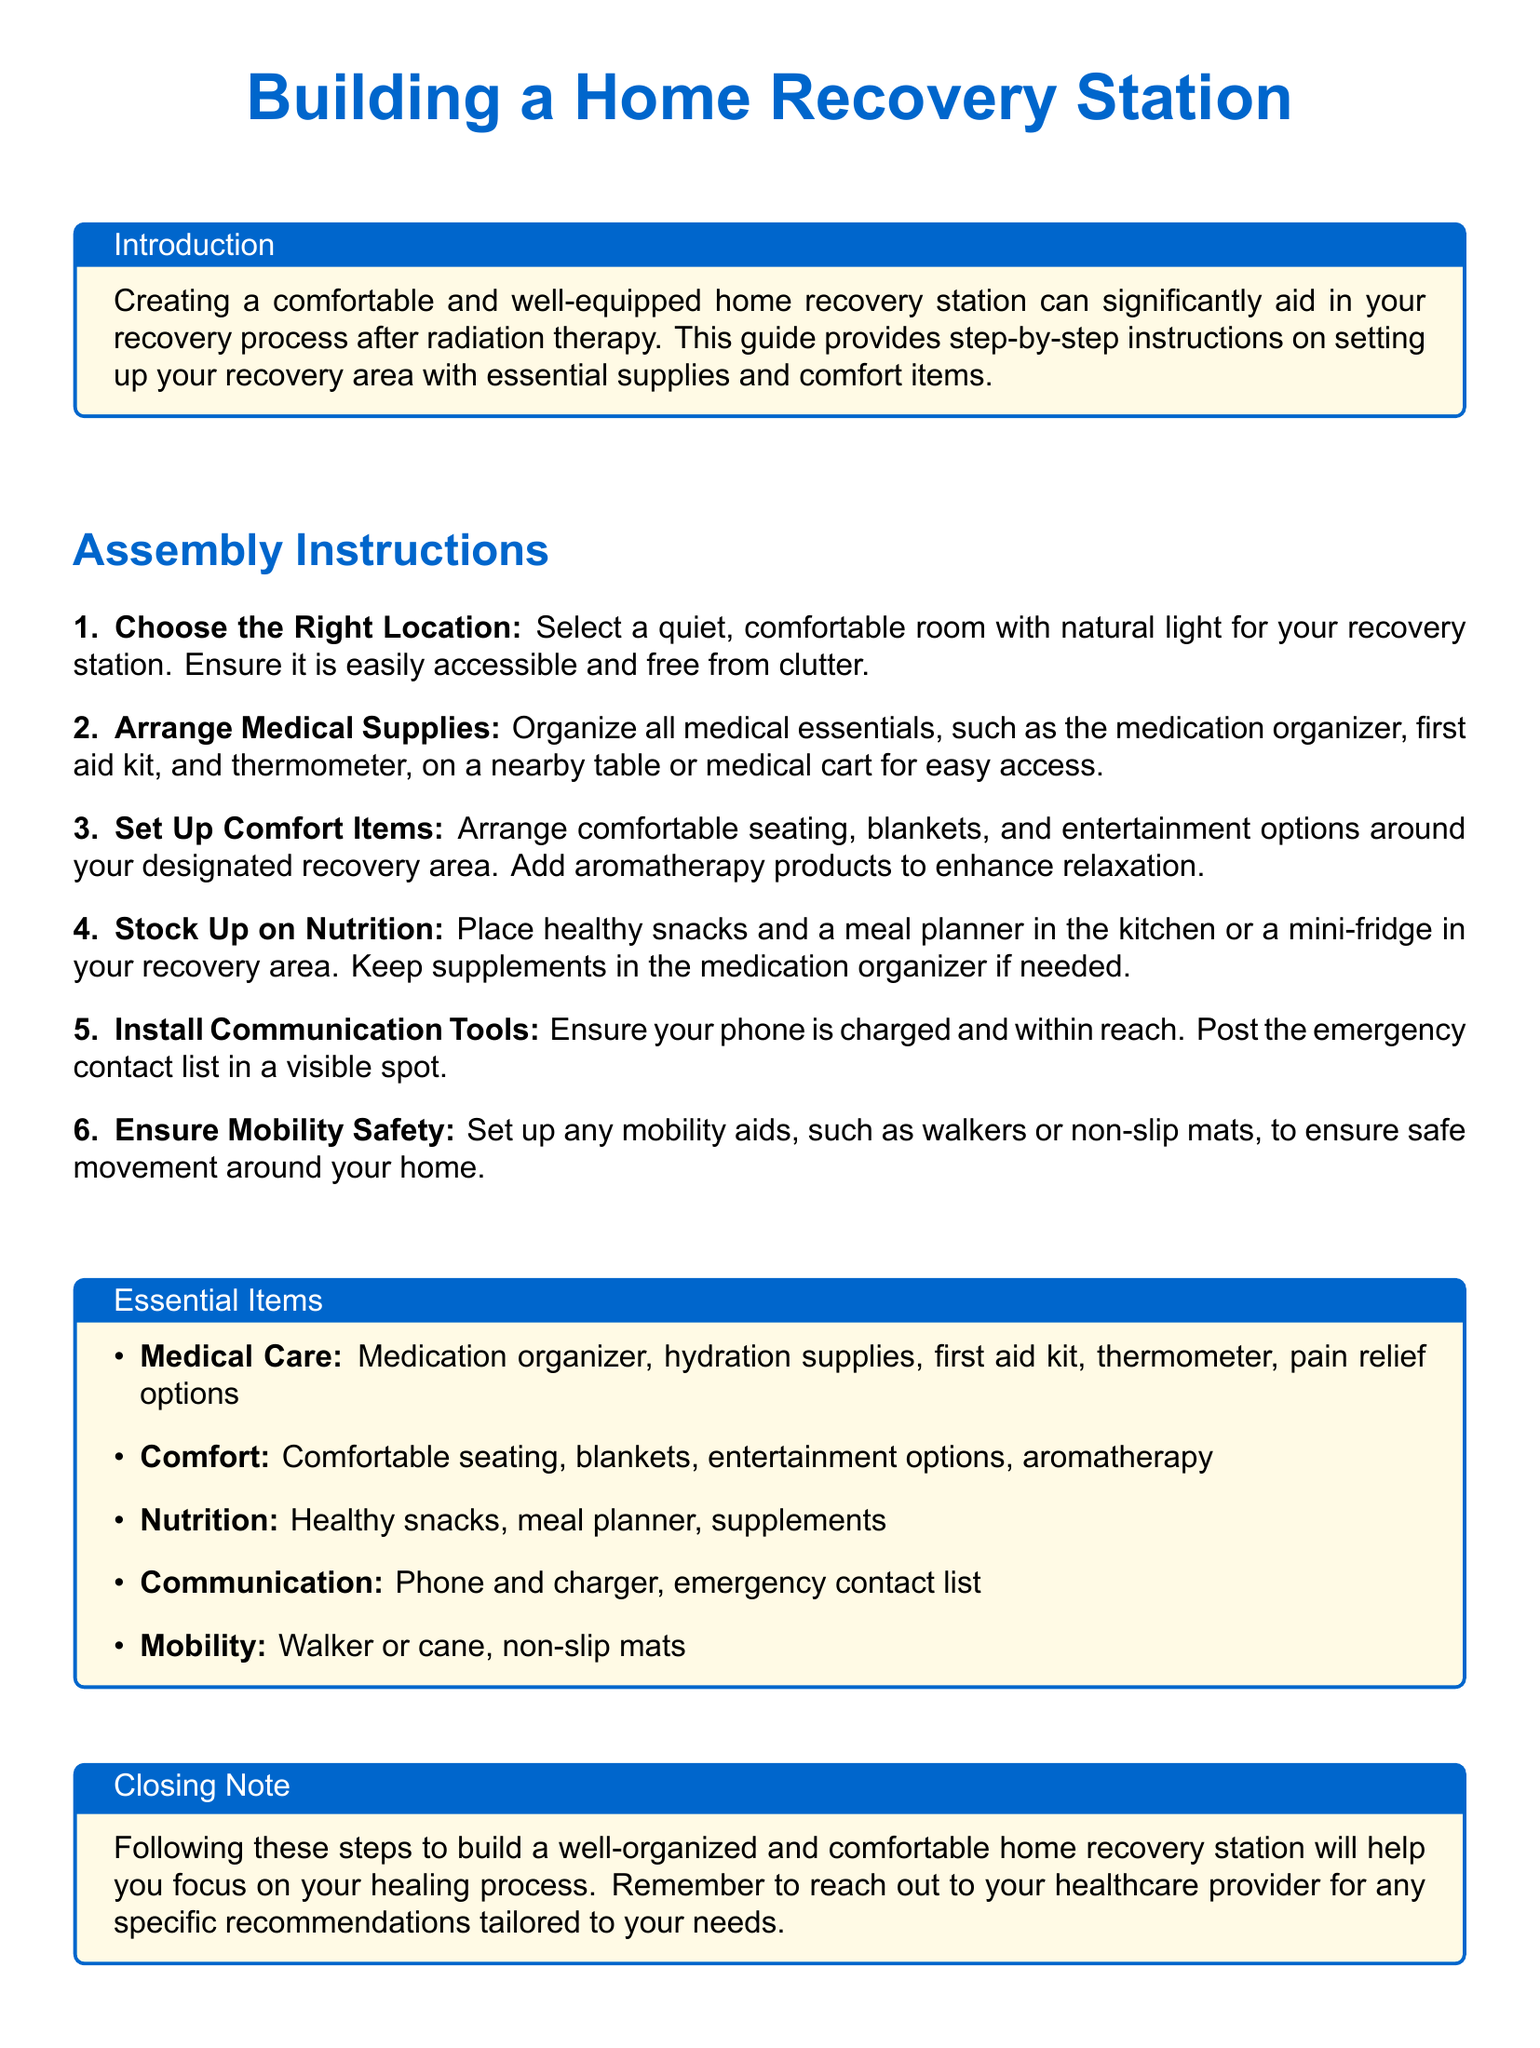What is the title of the document? The title is prominently displayed at the top of the document and is "Building a Home Recovery Station."
Answer: Building a Home Recovery Station What color is the main color used in the document? The document uses an RGB color code for the main color, which is specified as RGB (0, 102, 204).
Answer: RGB(0,102,204) How many steps are included in the assembly instructions? The document lists a total of six steps in the assembly instructions section.
Answer: 6 What item is suggested for enhancing relaxation? The document mentions aromatherapy products as a comfort item for relaxation.
Answer: Aromatherapy products What should be in a visible spot according to the instructions? The document advises posting the emergency contact list in a visible spot for easy accessibility.
Answer: Emergency contact list What type of fridge is mentioned for the recovery area? The document suggests using a mini-fridge in the recovery area for storing nutrition items.
Answer: Mini-fridge Which mobility aid is referenced for safety? The document refers to a walker or cane as part of mobility safety.
Answer: Walker or cane What should be organized on a nearby table or medical cart? The document specifies organizing medical essentials for easy access on a nearby table or medical cart.
Answer: Medical essentials 